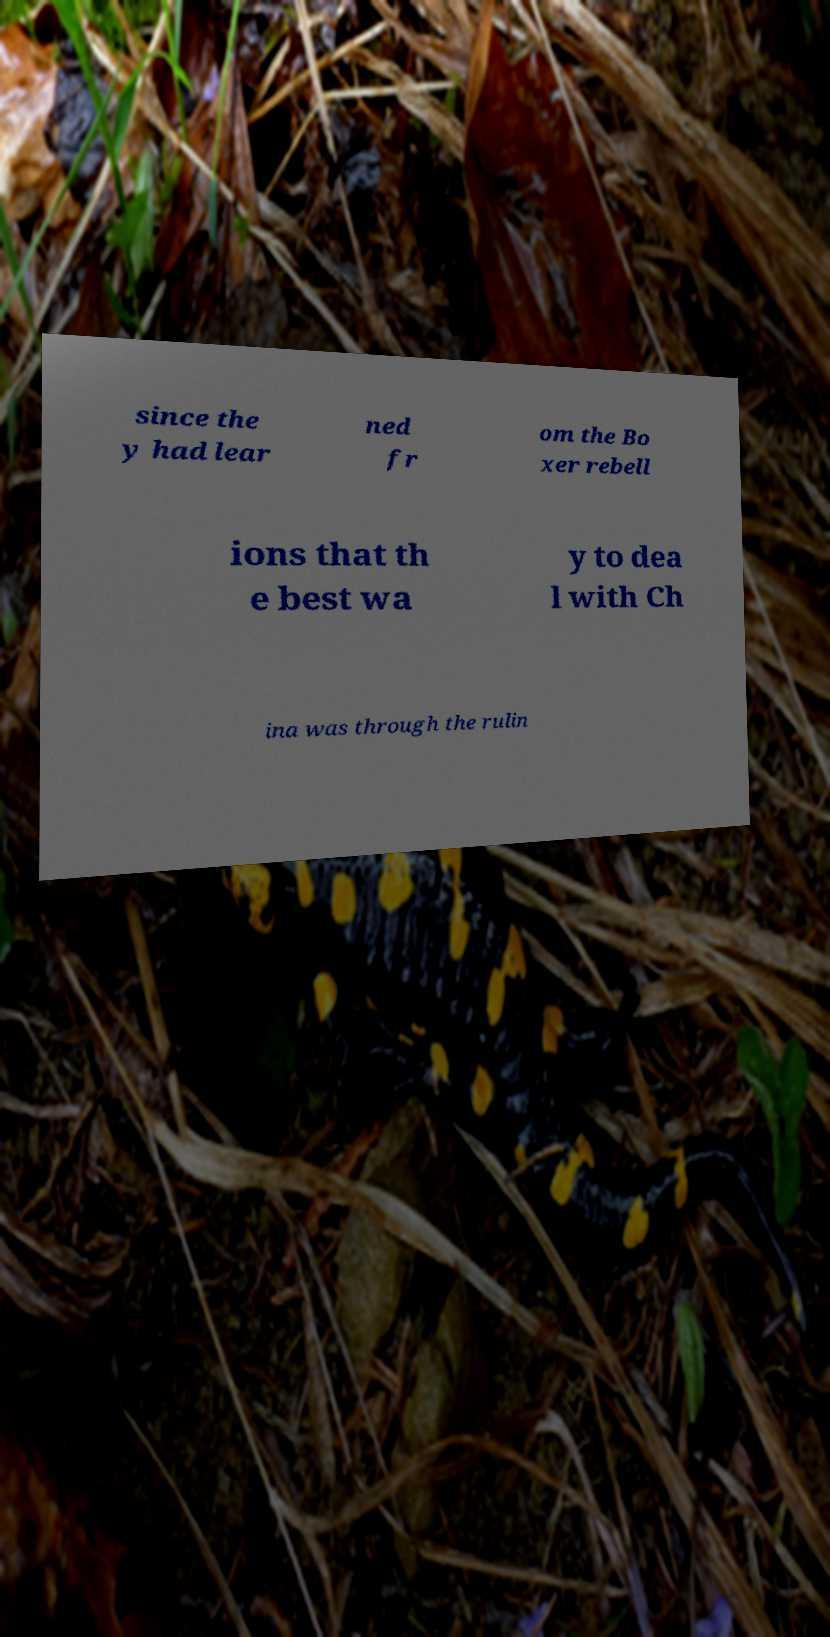Can you read and provide the text displayed in the image?This photo seems to have some interesting text. Can you extract and type it out for me? since the y had lear ned fr om the Bo xer rebell ions that th e best wa y to dea l with Ch ina was through the rulin 